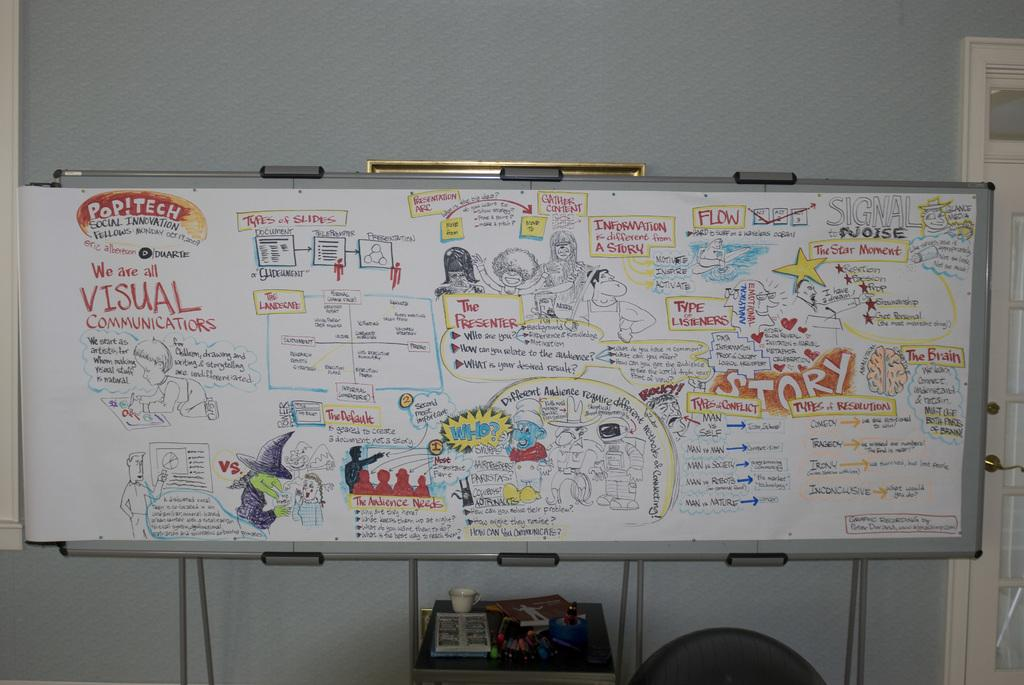What is the main object in the image? There is a board in the image. What is depicted on the board? The board contains a drawing of people and text. What can be seen on the table under the board? There are objects on a table under the board. What is visible in the background of the image? There is a wall and a door in the background of the image. What news is being reported on the faucet in the image? There is no faucet present in the image, and therefore no news can be reported on it. 